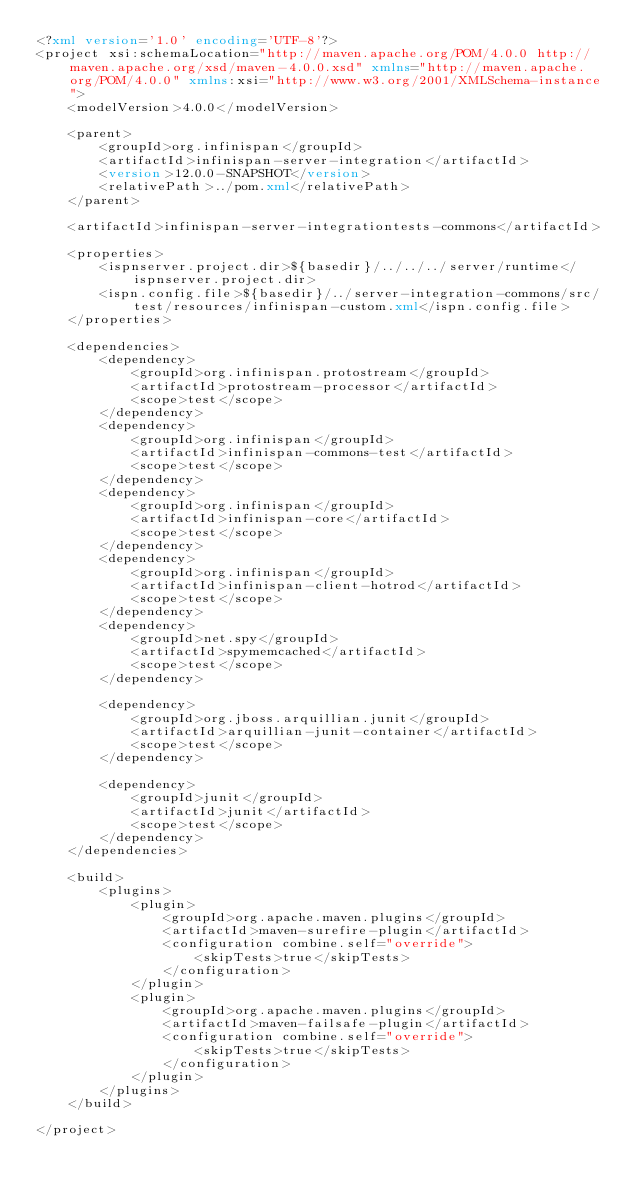<code> <loc_0><loc_0><loc_500><loc_500><_XML_><?xml version='1.0' encoding='UTF-8'?>
<project xsi:schemaLocation="http://maven.apache.org/POM/4.0.0 http://maven.apache.org/xsd/maven-4.0.0.xsd" xmlns="http://maven.apache.org/POM/4.0.0" xmlns:xsi="http://www.w3.org/2001/XMLSchema-instance">
    <modelVersion>4.0.0</modelVersion>

    <parent>
        <groupId>org.infinispan</groupId>
        <artifactId>infinispan-server-integration</artifactId>
        <version>12.0.0-SNAPSHOT</version>
        <relativePath>../pom.xml</relativePath>
    </parent>

    <artifactId>infinispan-server-integrationtests-commons</artifactId>

    <properties>
        <ispnserver.project.dir>${basedir}/../../../server/runtime</ispnserver.project.dir>
        <ispn.config.file>${basedir}/../server-integration-commons/src/test/resources/infinispan-custom.xml</ispn.config.file>
    </properties>

    <dependencies>
        <dependency>
            <groupId>org.infinispan.protostream</groupId>
            <artifactId>protostream-processor</artifactId>
            <scope>test</scope>
        </dependency>
        <dependency>
            <groupId>org.infinispan</groupId>
            <artifactId>infinispan-commons-test</artifactId>
            <scope>test</scope>
        </dependency>
        <dependency>
            <groupId>org.infinispan</groupId>
            <artifactId>infinispan-core</artifactId>
            <scope>test</scope>
        </dependency>
        <dependency>
            <groupId>org.infinispan</groupId>
            <artifactId>infinispan-client-hotrod</artifactId>
            <scope>test</scope>
        </dependency>
        <dependency>
            <groupId>net.spy</groupId>
            <artifactId>spymemcached</artifactId>
            <scope>test</scope>
        </dependency>

        <dependency>
            <groupId>org.jboss.arquillian.junit</groupId>
            <artifactId>arquillian-junit-container</artifactId>
            <scope>test</scope>
        </dependency>

        <dependency>
            <groupId>junit</groupId>
            <artifactId>junit</artifactId>
            <scope>test</scope>
        </dependency>
    </dependencies>

    <build>
        <plugins>
            <plugin>
                <groupId>org.apache.maven.plugins</groupId>
                <artifactId>maven-surefire-plugin</artifactId>
                <configuration combine.self="override">
                    <skipTests>true</skipTests>
                </configuration>
            </plugin>
            <plugin>
                <groupId>org.apache.maven.plugins</groupId>
                <artifactId>maven-failsafe-plugin</artifactId>
                <configuration combine.self="override">
                    <skipTests>true</skipTests>
                </configuration>
            </plugin>
        </plugins>
    </build>

</project>
</code> 